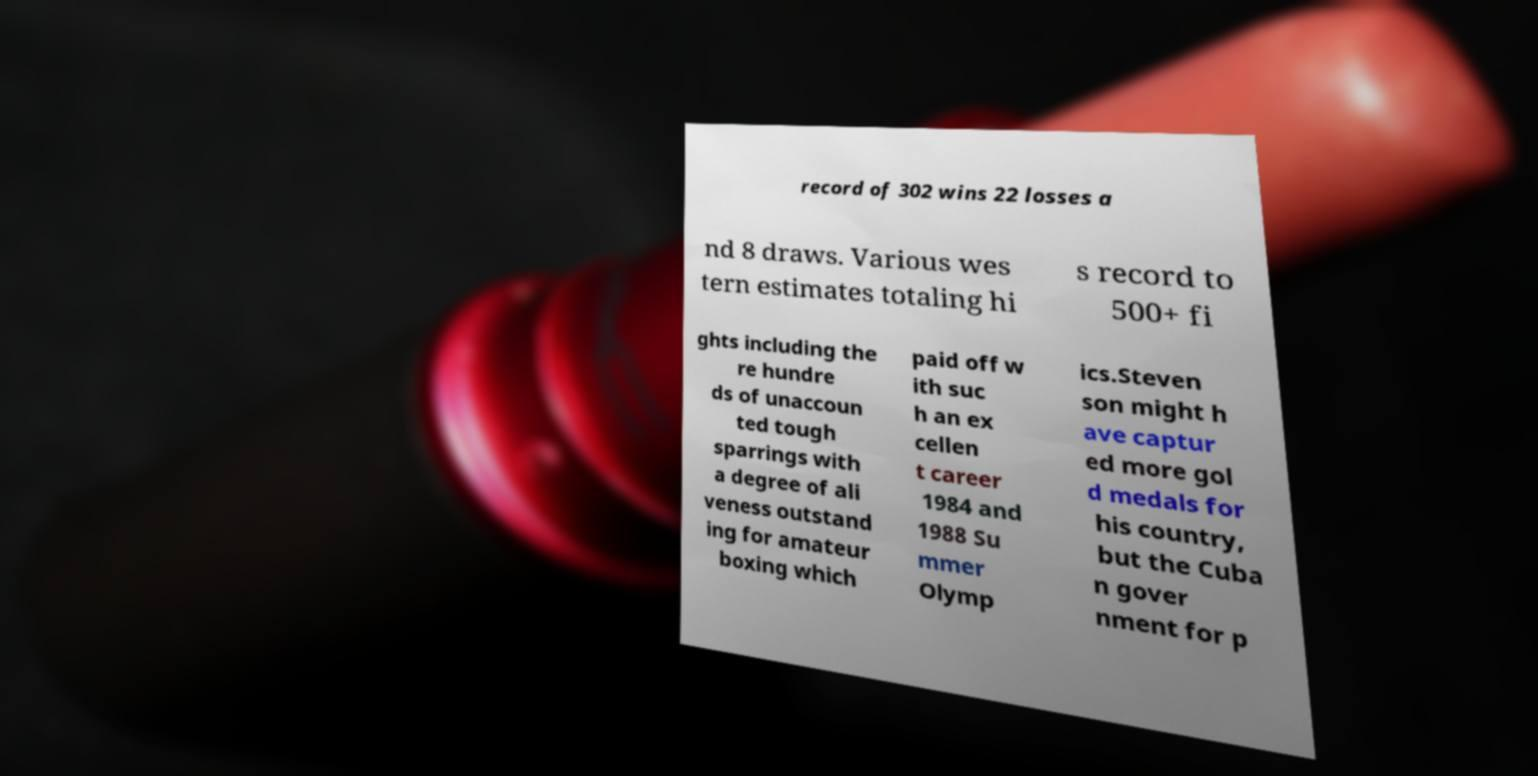For documentation purposes, I need the text within this image transcribed. Could you provide that? record of 302 wins 22 losses a nd 8 draws. Various wes tern estimates totaling hi s record to 500+ fi ghts including the re hundre ds of unaccoun ted tough sparrings with a degree of ali veness outstand ing for amateur boxing which paid off w ith suc h an ex cellen t career 1984 and 1988 Su mmer Olymp ics.Steven son might h ave captur ed more gol d medals for his country, but the Cuba n gover nment for p 